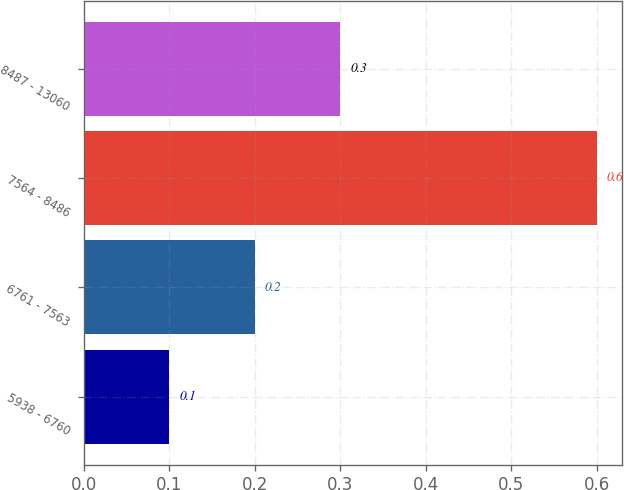<chart> <loc_0><loc_0><loc_500><loc_500><bar_chart><fcel>5938 - 6760<fcel>6761 - 7563<fcel>7564 - 8486<fcel>8487 - 13060<nl><fcel>0.1<fcel>0.2<fcel>0.6<fcel>0.3<nl></chart> 